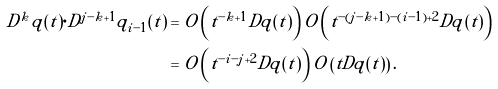Convert formula to latex. <formula><loc_0><loc_0><loc_500><loc_500>D ^ { k } q ( t ) \cdot D ^ { j - k + 1 } q _ { i - 1 } ( t ) & = O \left ( t ^ { - k + 1 } D q ( t ) \right ) O \left ( t ^ { - ( j - k + 1 ) - ( i - 1 ) + 2 } D q ( t ) \right ) \\ & = O \left ( t ^ { - i - j + 2 } D q ( t ) \right ) O \left ( t D q ( t ) \right ) .</formula> 